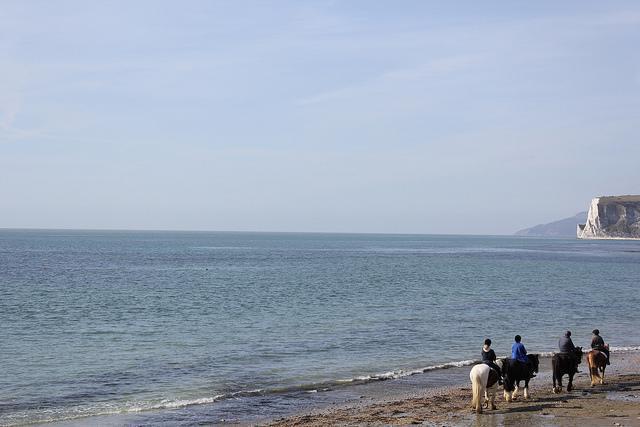What is the first terrain on the right?
Answer the question by selecting the correct answer among the 4 following choices and explain your choice with a short sentence. The answer should be formatted with the following format: `Answer: choice
Rationale: rationale.`
Options: Cliff, savanna, valley, mountain. Answer: cliff.
Rationale: In the distance behind the water to the right we see the topology defining a cliff. 